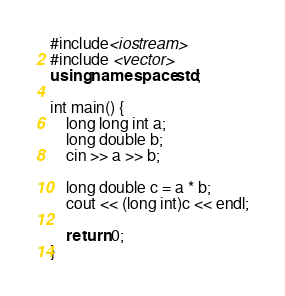Convert code to text. <code><loc_0><loc_0><loc_500><loc_500><_C++_>#include<iostream>
#include <vector>
using namespace std;

int main() {
	long long int a;
	long double b;
	cin >> a >> b;

	long double c = a * b;
	cout << (long int)c << endl;

	return 0;
}
</code> 